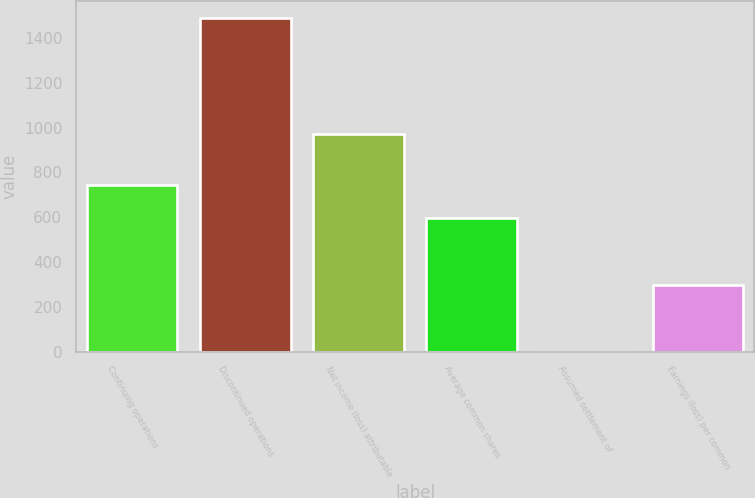Convert chart to OTSL. <chart><loc_0><loc_0><loc_500><loc_500><bar_chart><fcel>Continuing operations<fcel>Discontinued operations<fcel>Net income (loss) attributable<fcel>Average common shares<fcel>Assumed settlement of<fcel>Earnings (loss) per common<nl><fcel>745.2<fcel>1490<fcel>974<fcel>596.24<fcel>0.4<fcel>298.32<nl></chart> 